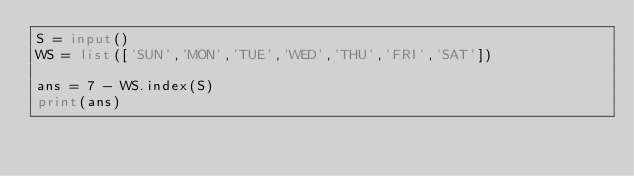Convert code to text. <code><loc_0><loc_0><loc_500><loc_500><_Python_>S = input()
WS = list(['SUN','MON','TUE','WED','THU','FRI','SAT'])

ans = 7 - WS.index(S)
print(ans)</code> 